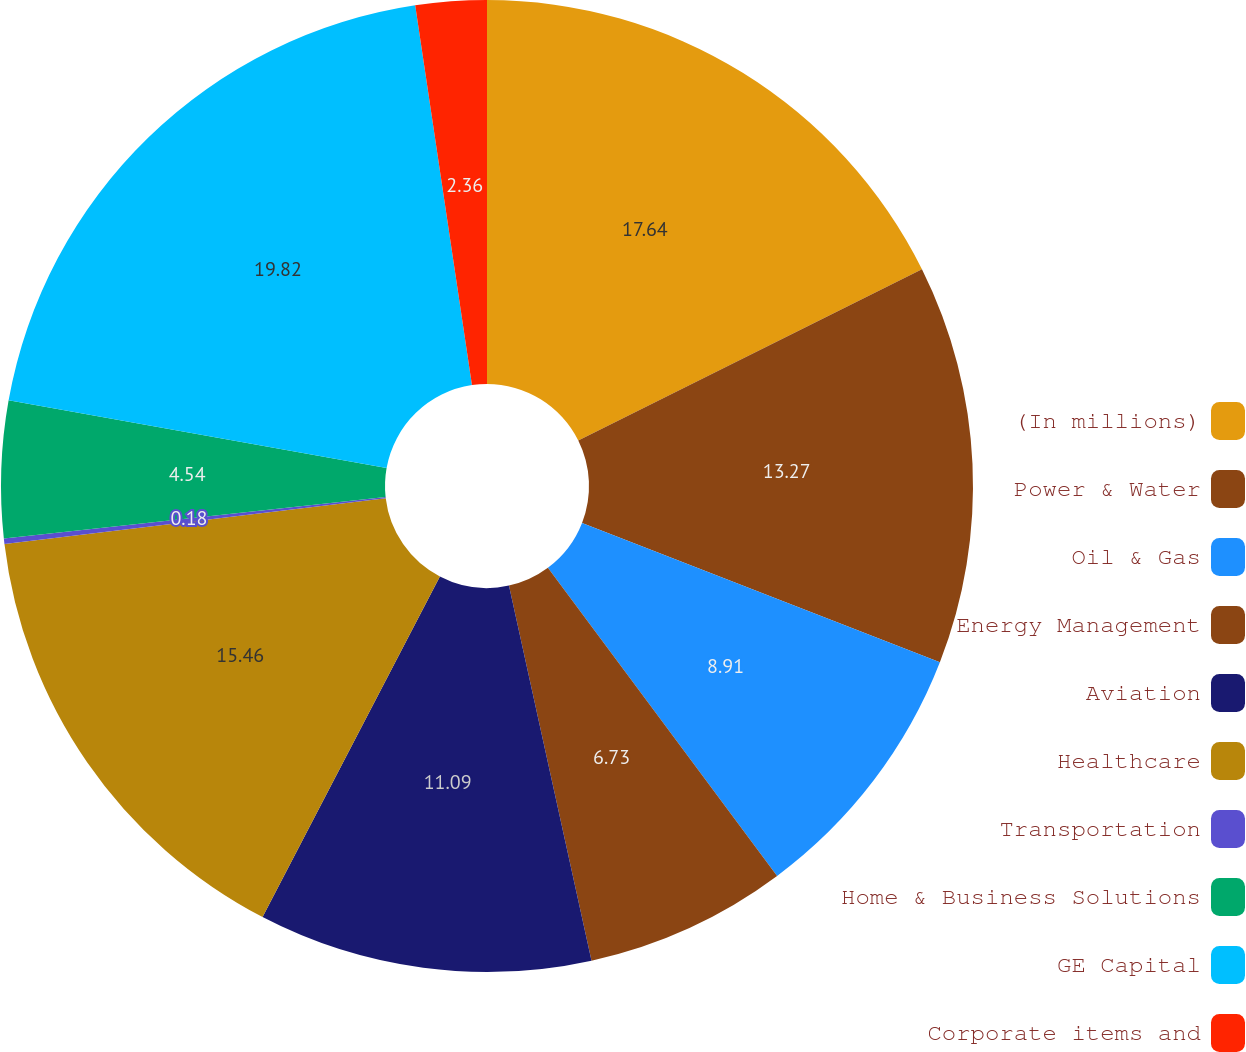Convert chart. <chart><loc_0><loc_0><loc_500><loc_500><pie_chart><fcel>(In millions)<fcel>Power & Water<fcel>Oil & Gas<fcel>Energy Management<fcel>Aviation<fcel>Healthcare<fcel>Transportation<fcel>Home & Business Solutions<fcel>GE Capital<fcel>Corporate items and<nl><fcel>17.64%<fcel>13.27%<fcel>8.91%<fcel>6.73%<fcel>11.09%<fcel>15.46%<fcel>0.18%<fcel>4.54%<fcel>19.82%<fcel>2.36%<nl></chart> 